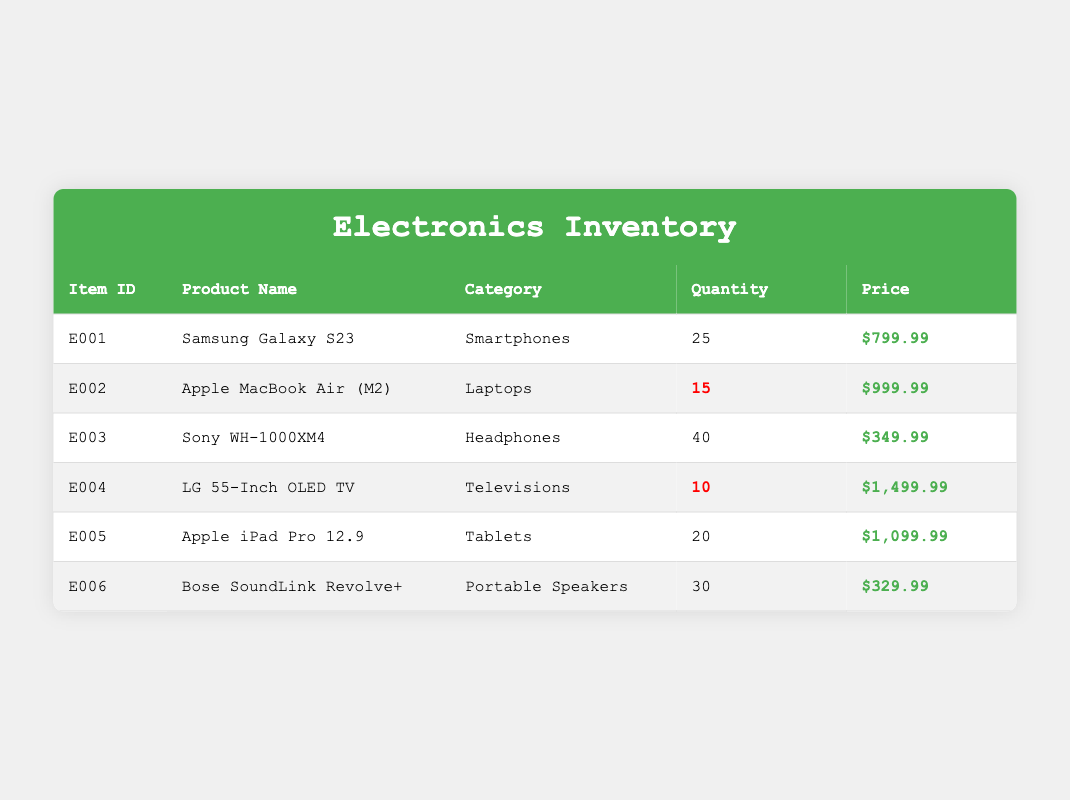What is the quantity of the Samsung Galaxy S23 in stock? The table lists the item "Samsung Galaxy S23" with a quantity of 25 in the "Quantity" column. Therefore, the quantity of the Samsung Galaxy S23 in stock is directly retrievable from the table.
Answer: 25 Which product has the highest price? By examining the "Price" column for each product, the LG 55-Inch OLED TV is priced at $1,499.99, which is higher than all other products listed. Thus, it is confirmed to be the product with the highest price.
Answer: LG 55-Inch OLED TV Is the quantity of Apple iPad Pro 12.9 greater than 15? The quantity of Apple iPad Pro 12.9 is indicated as 20 in the "Quantity" column, confirming that it is indeed greater than 15. Hence, the answer to this question is affirmative based on the retrieved data.
Answer: Yes What is the total quantity of all products in stock? To find the total quantity, sum the quantities of all products: 25 (Samsung Galaxy S23) + 15 (Apple MacBook Air) + 40 (Sony WH-1000XM4) + 10 (LG 55-Inch OLED TV) + 20 (Apple iPad Pro) + 30 (Bose SoundLink) = 140. This adds all quantities listed together to provide the total count.
Answer: 140 Are there more than 20 units of headphones in stock? The quantity for Sony WH-1000XM4 headphones is 40, which is greater than 20. The question is answered by checking the specific quantity in the "Quantity" column.
Answer: Yes How many products have a quantity labeled as low stock? By reviewing the "Quantity" column entries marked with low stock, there are two products: Apple MacBook Air (15) and LG 55-Inch OLED TV (10). Counting them gives a total of two products in low stock.
Answer: 2 Which product is the least expensive? By comparing all entries in the "Price" column, the lowest price is for Bose SoundLink Revolve+ at $329.99. This involves evaluating and identifying the minimum price among all products listed.
Answer: Bose SoundLink Revolve+ What is the average stock level of the electronics listed? To calculate the average, first sum all quantities: 25 + 15 + 40 + 10 + 20 + 30 = 140. Then divide by the number of products, which is 6. Therefore, the average stock level is 140/6 ≈ 23.33, giving a clear measure of stock per product.
Answer: 23.33 Does the store have any televisions in stock? The inventory includes one television, the LG 55-Inch OLED TV, which has a quantity of 10. By verifying the "Category" column, I confirm that there is indeed a television product available.
Answer: Yes 